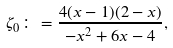<formula> <loc_0><loc_0><loc_500><loc_500>\zeta _ { 0 } \colon = \frac { 4 ( x - 1 ) ( 2 - x ) } { - x ^ { 2 } + 6 x - 4 } ,</formula> 